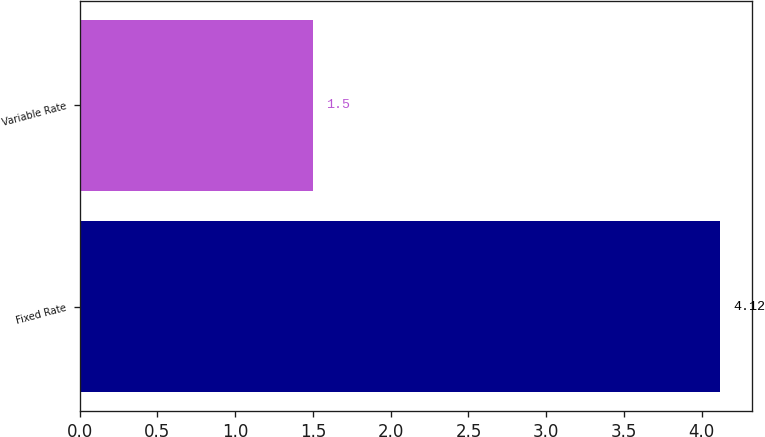Convert chart to OTSL. <chart><loc_0><loc_0><loc_500><loc_500><bar_chart><fcel>Fixed Rate<fcel>Variable Rate<nl><fcel>4.12<fcel>1.5<nl></chart> 